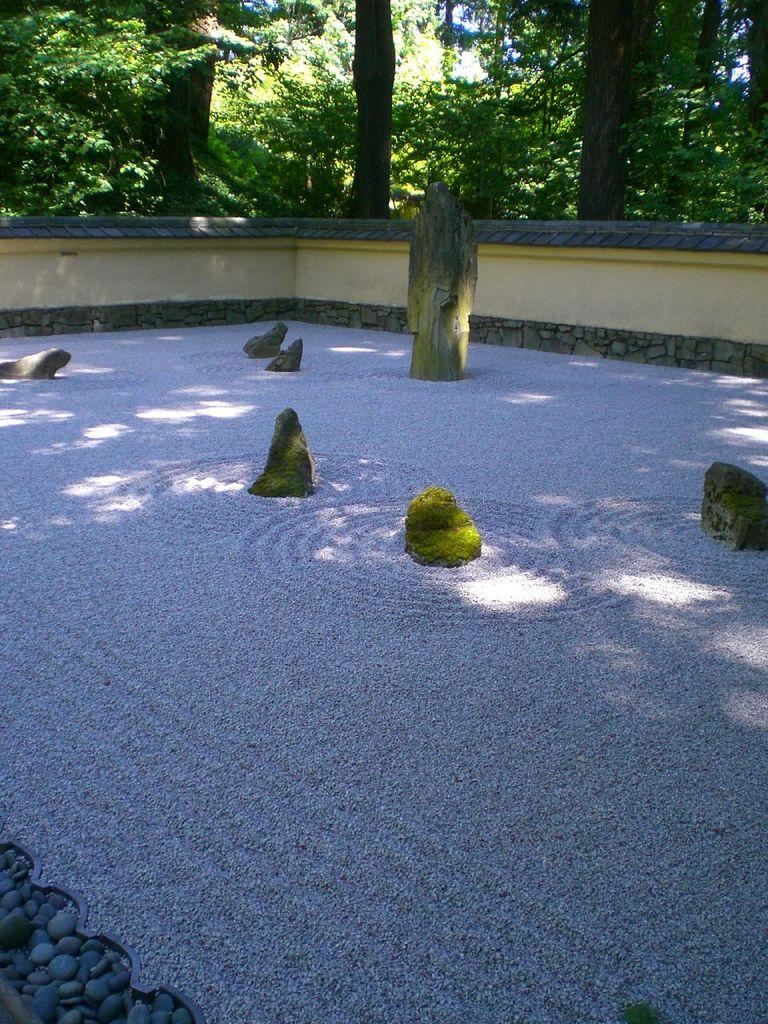What is located in the center of the image? There are stones in the center of the image. What can be seen in the background of the image? There are trees in the background of the image. What else is visible on the ground in the image? Shadows are visible on the ground. What letters are written on the stones in the image? There are no letters written on the stones in the image; they are just stones. How many lizards can be seen crawling on the trees in the image? There are no lizards present in the image; it only features stones and trees. 